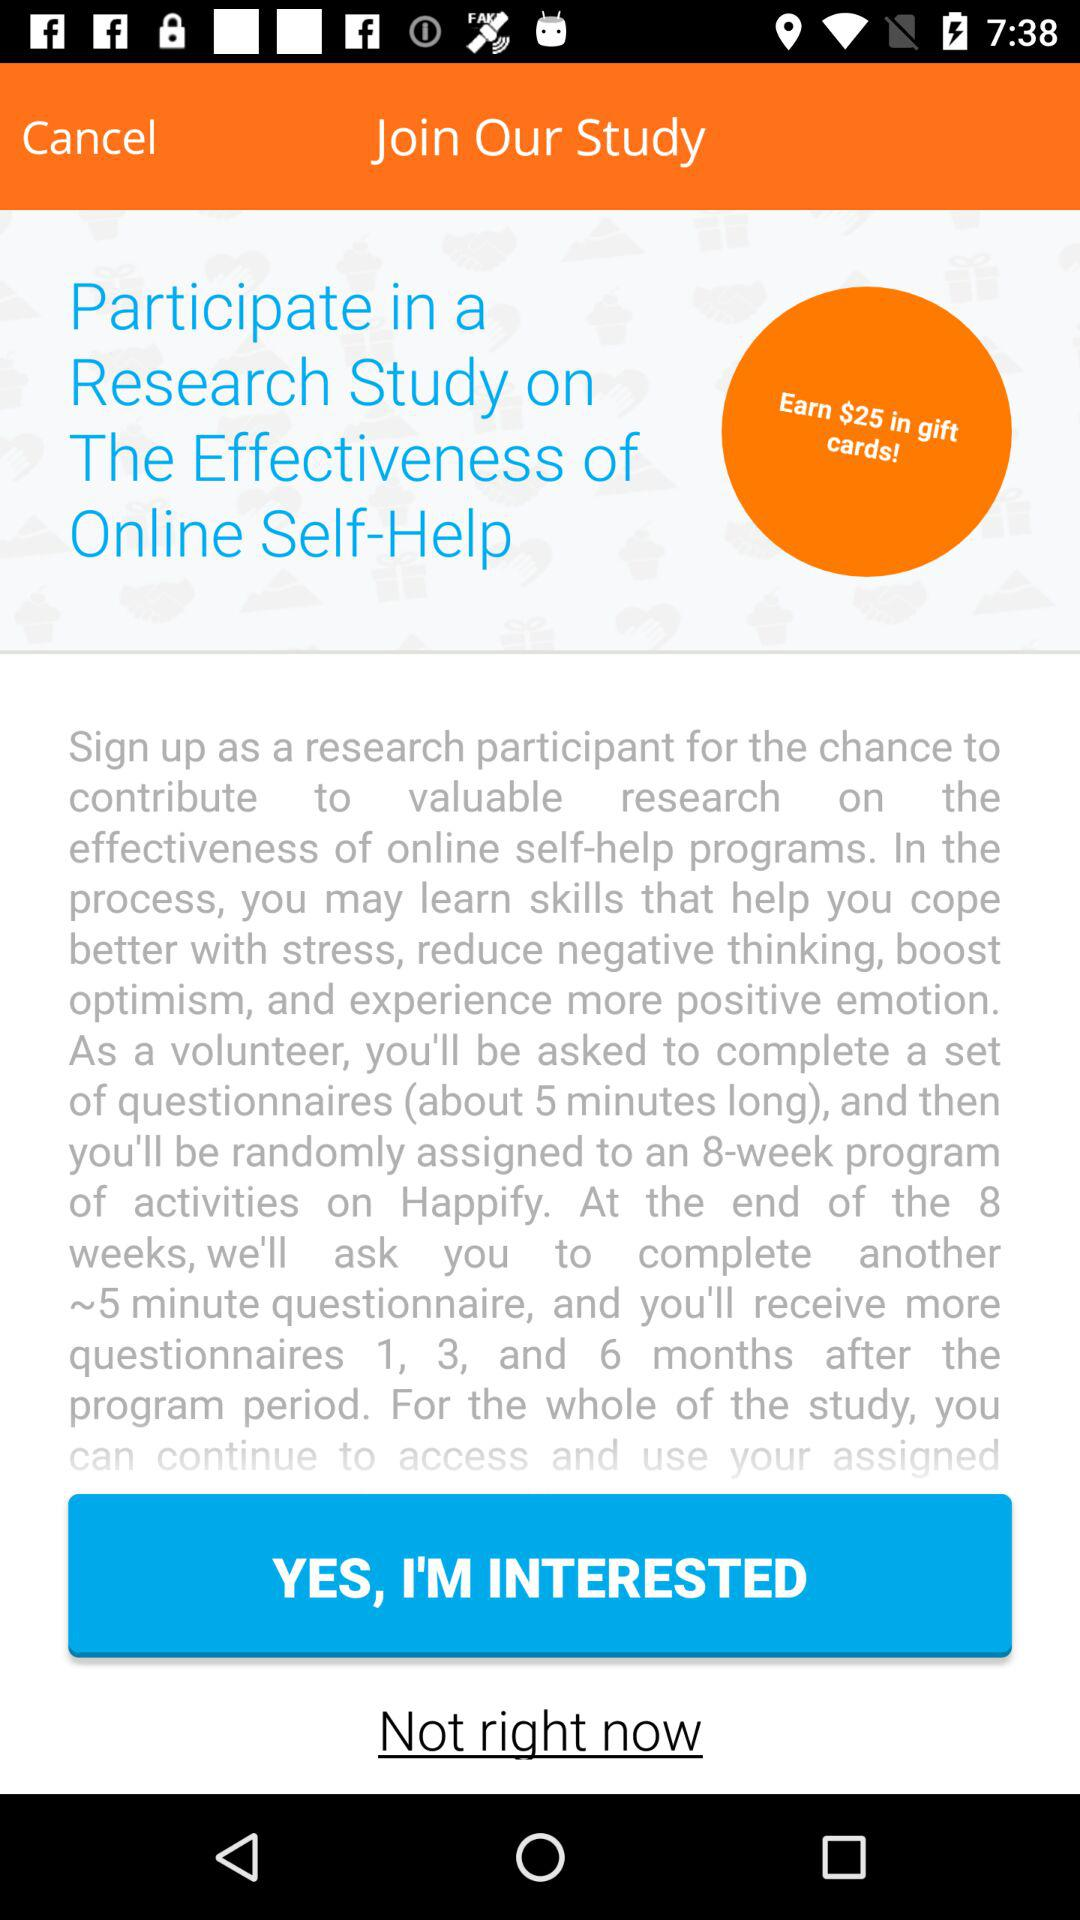How long will we receive the questionnaire after the program period? You will receive the questionnaires 1, 3, and 6 months after the program period. 